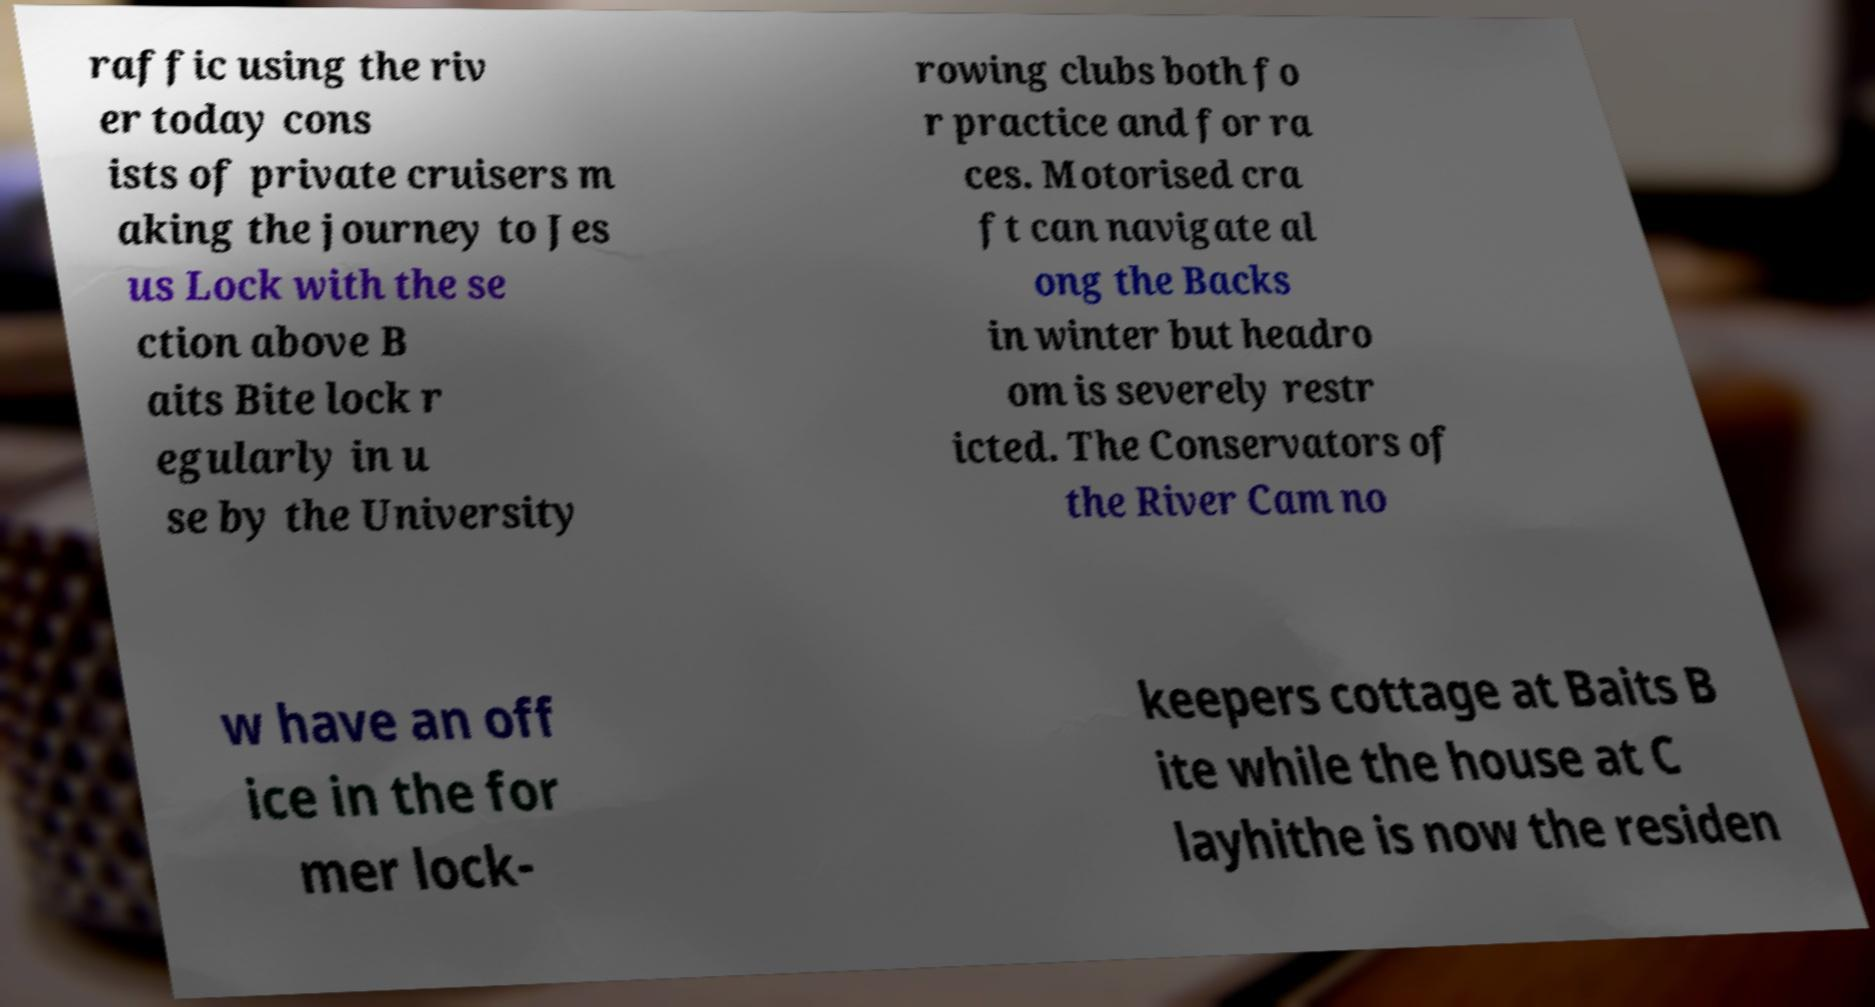Please read and relay the text visible in this image. What does it say? raffic using the riv er today cons ists of private cruisers m aking the journey to Jes us Lock with the se ction above B aits Bite lock r egularly in u se by the University rowing clubs both fo r practice and for ra ces. Motorised cra ft can navigate al ong the Backs in winter but headro om is severely restr icted. The Conservators of the River Cam no w have an off ice in the for mer lock- keepers cottage at Baits B ite while the house at C layhithe is now the residen 